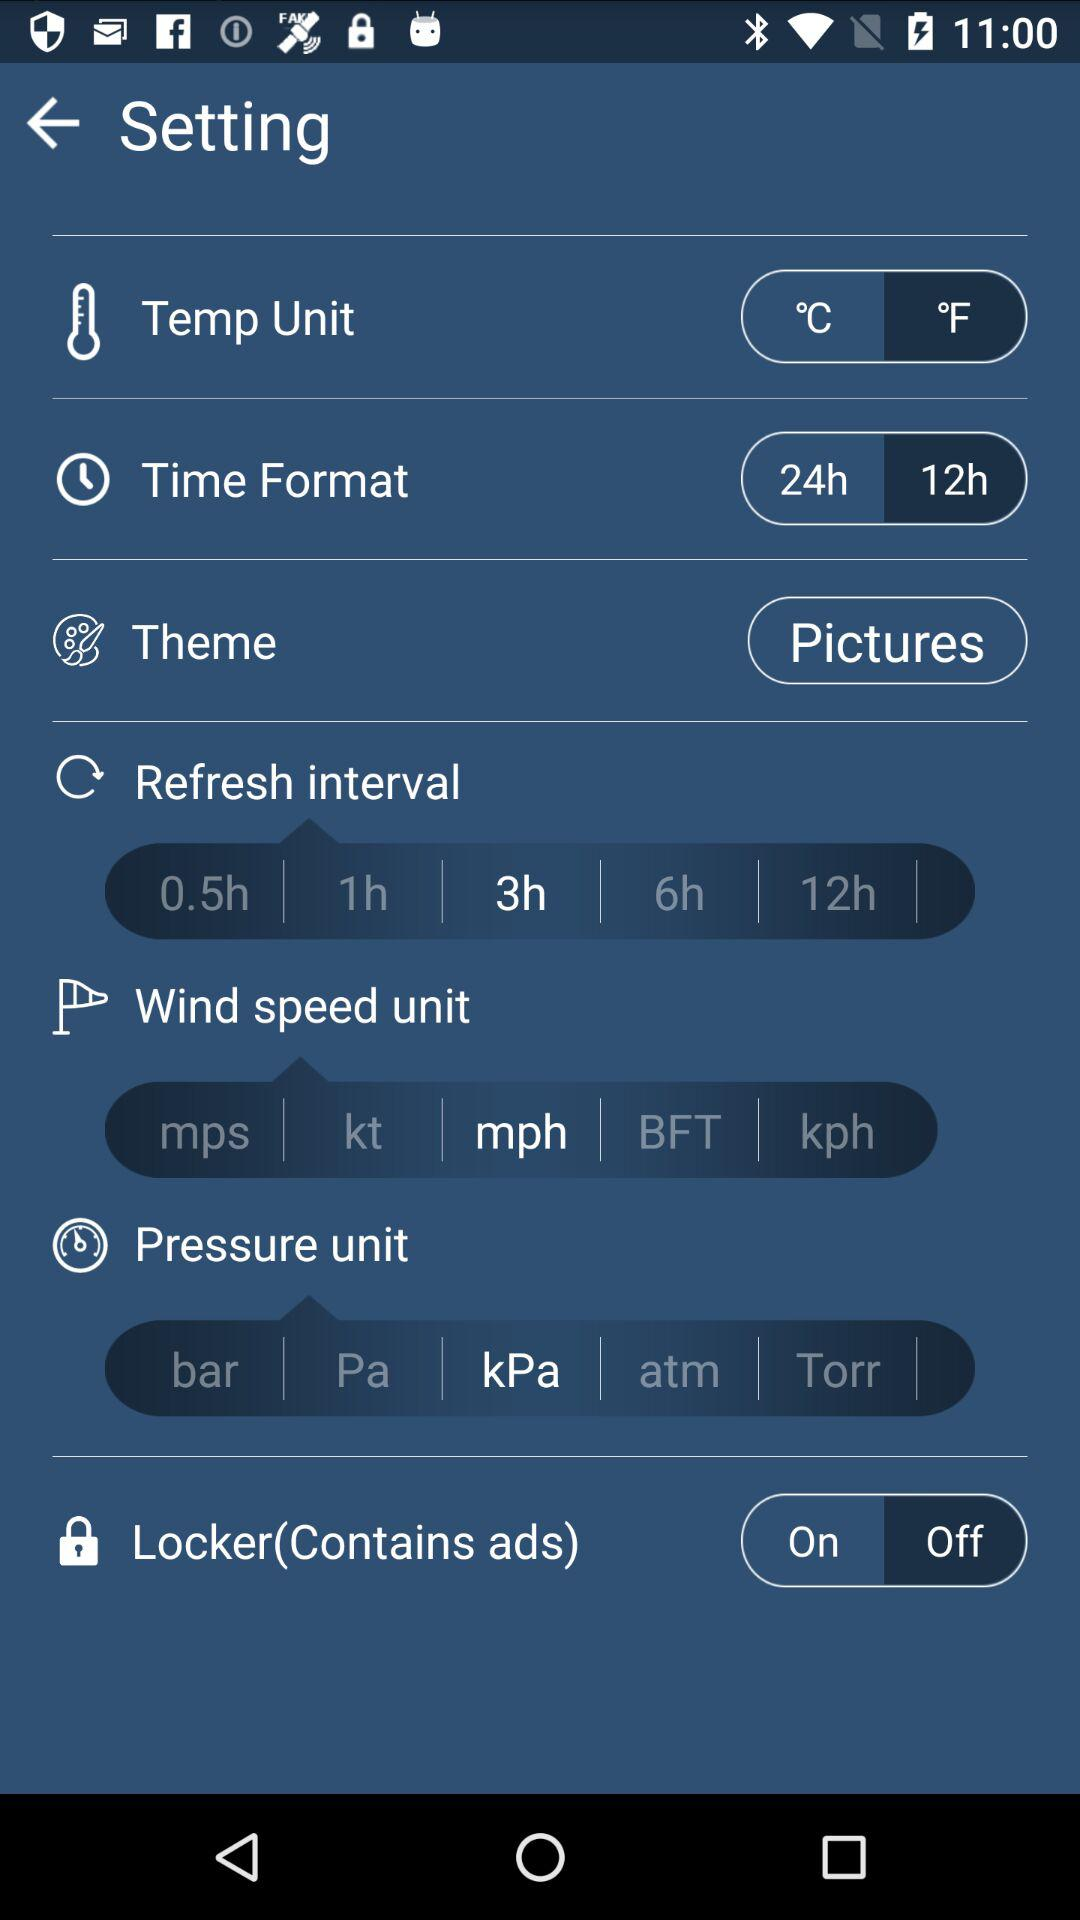What is the setting for "Temp Unit"? The setting for "Temp Unit" is °F. 